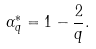Convert formula to latex. <formula><loc_0><loc_0><loc_500><loc_500>\alpha _ { q } ^ { * } = 1 - \frac { 2 } { q } .</formula> 